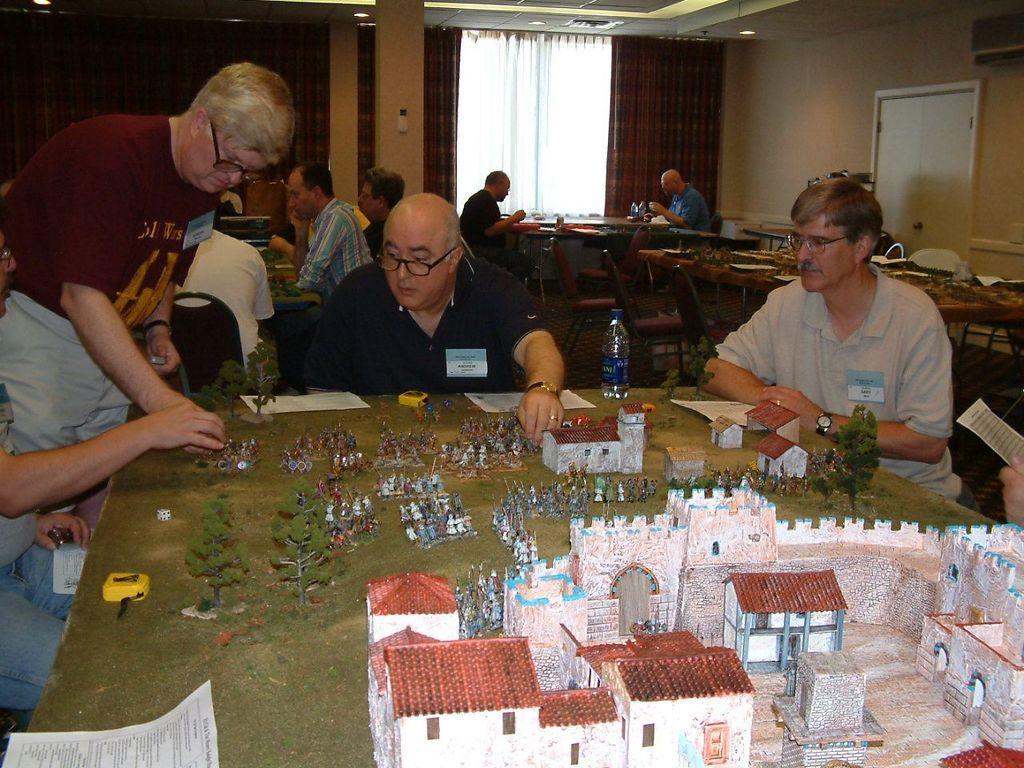How would you summarize this image in a sentence or two? In this image there are few people who are sitting around the table on which there is a project which describes about the castle and people around it. In the background there are two people who are sitting near the table and eating and there is also a curtain at the back side. 